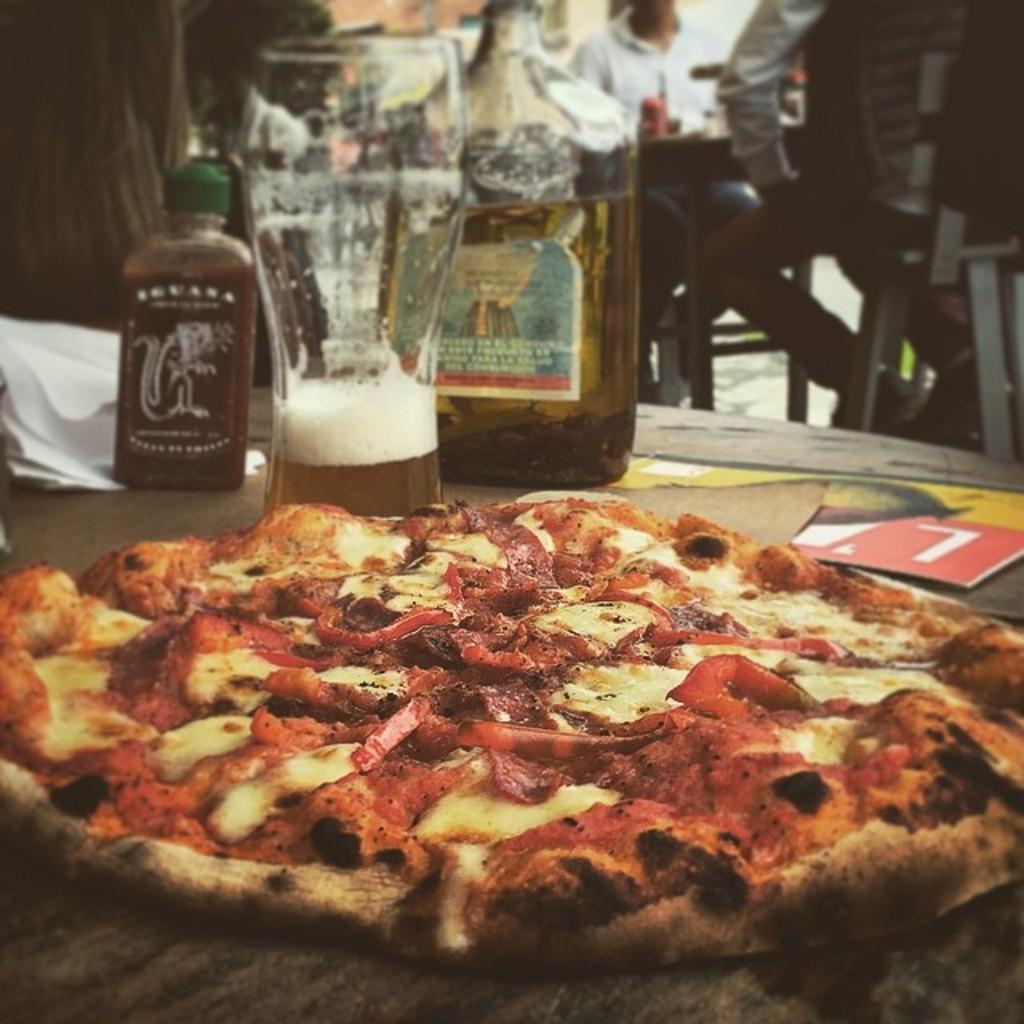How would you summarize this image in a sentence or two? In this picture, we can see a few people, and we can see the ground with some objects like chairs, and table, we can see some objects on the table like some food item, glass, bottle with liquid in it. 